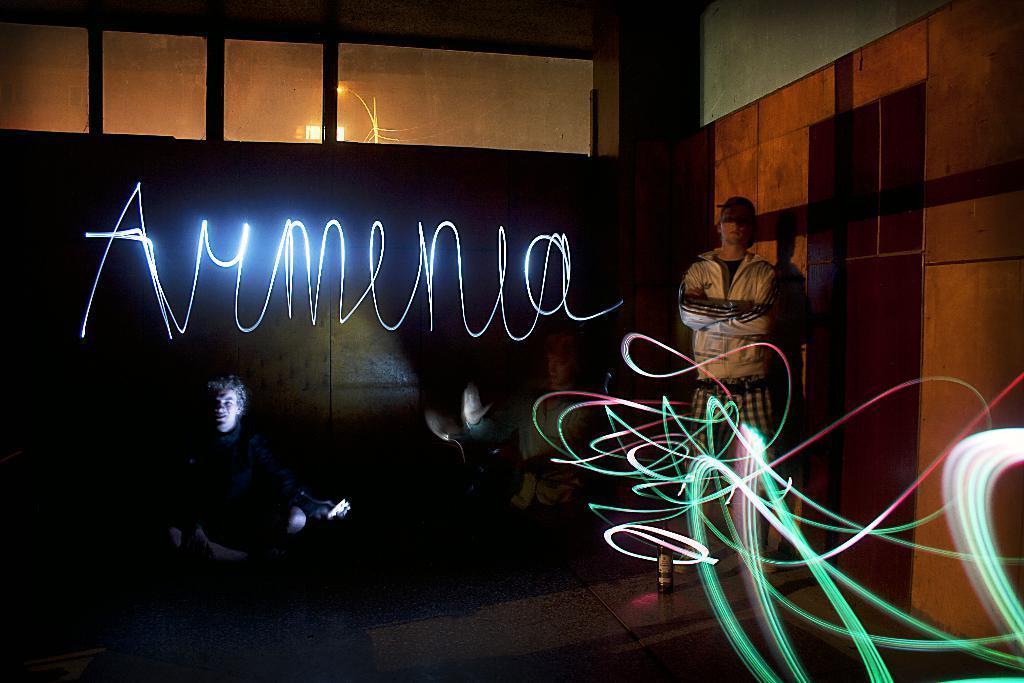In one or two sentences, can you explain what this image depicts? In this picture we can see the view of the dark room. In the front there is a boy wearing a jacket and standing in the front. Beside we can see another boy sitting and holding the mobile phone. Behind there is a wooden panel wall and glass window. In the front we can see some laser light reflection. 